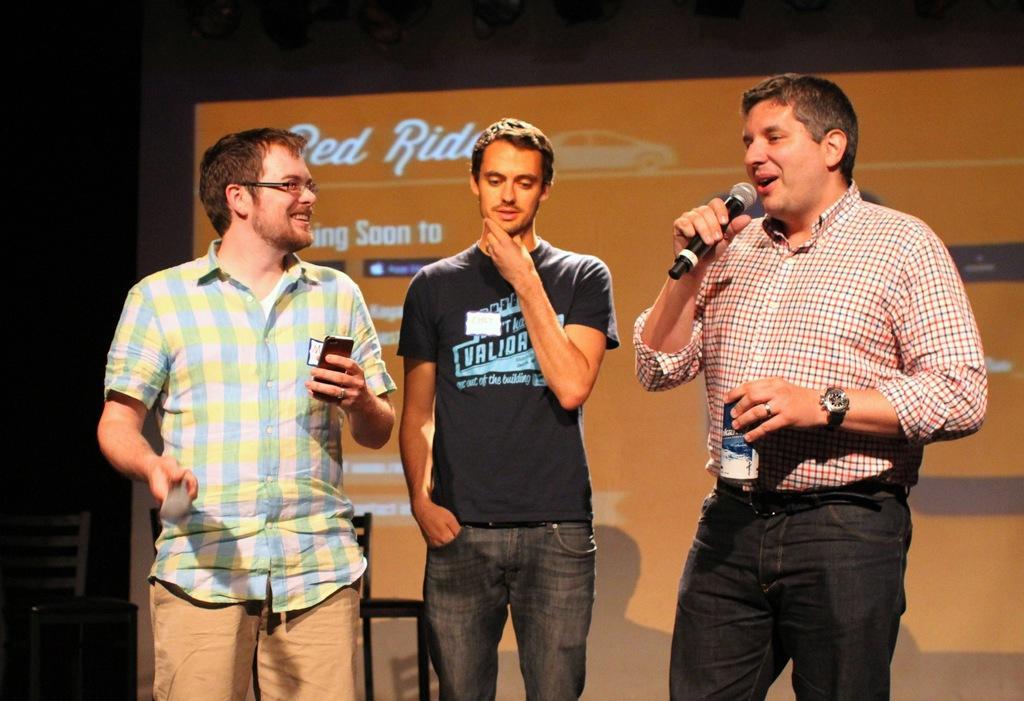Could you give a brief overview of what you see in this image? This is a picture taken on a stage, where are the three people standing on the stage. The man in checks shirt holding the microphone and a tin and the man in white and yellow, blue checks shirt holding the mobile phone. Background of this people there is banner which is in black and orange color. 